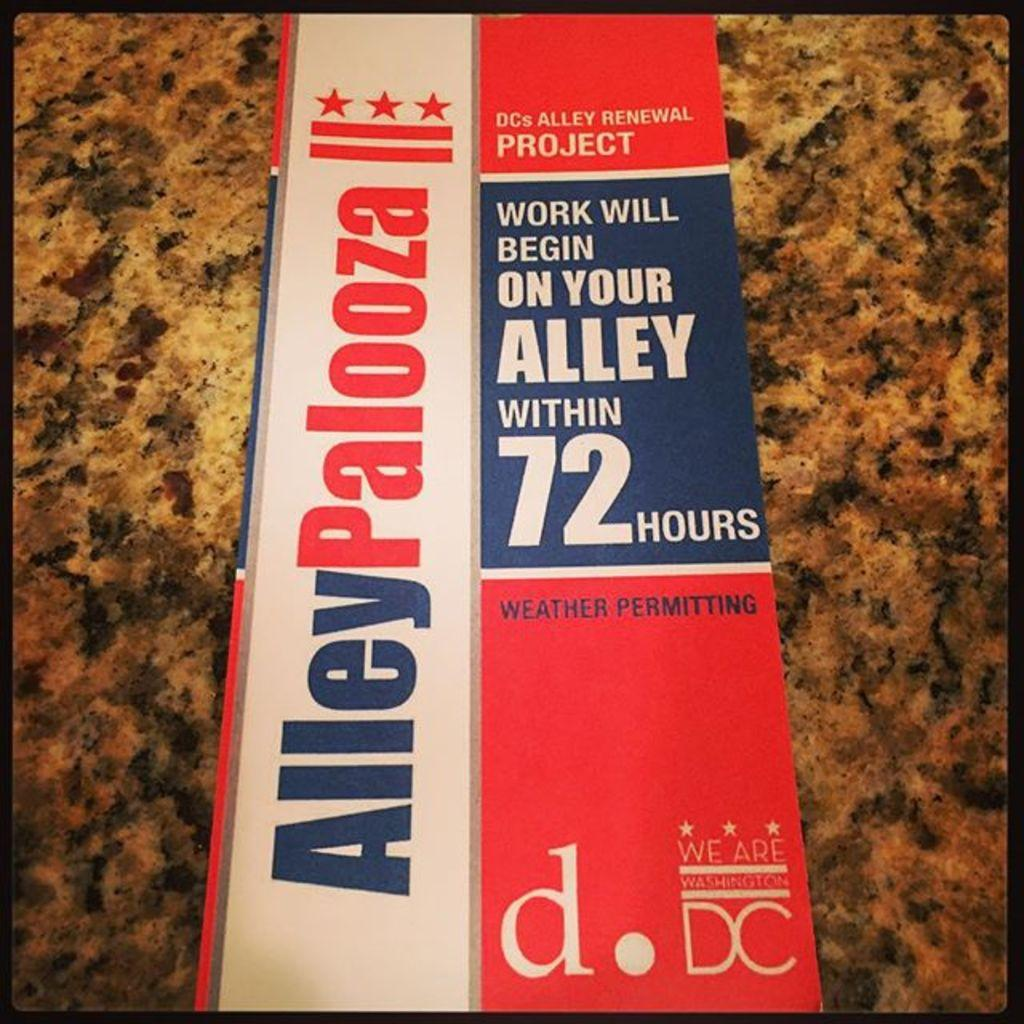<image>
Relay a brief, clear account of the picture shown. The Alley Renewal Project promises work will begin within 72 hours. 